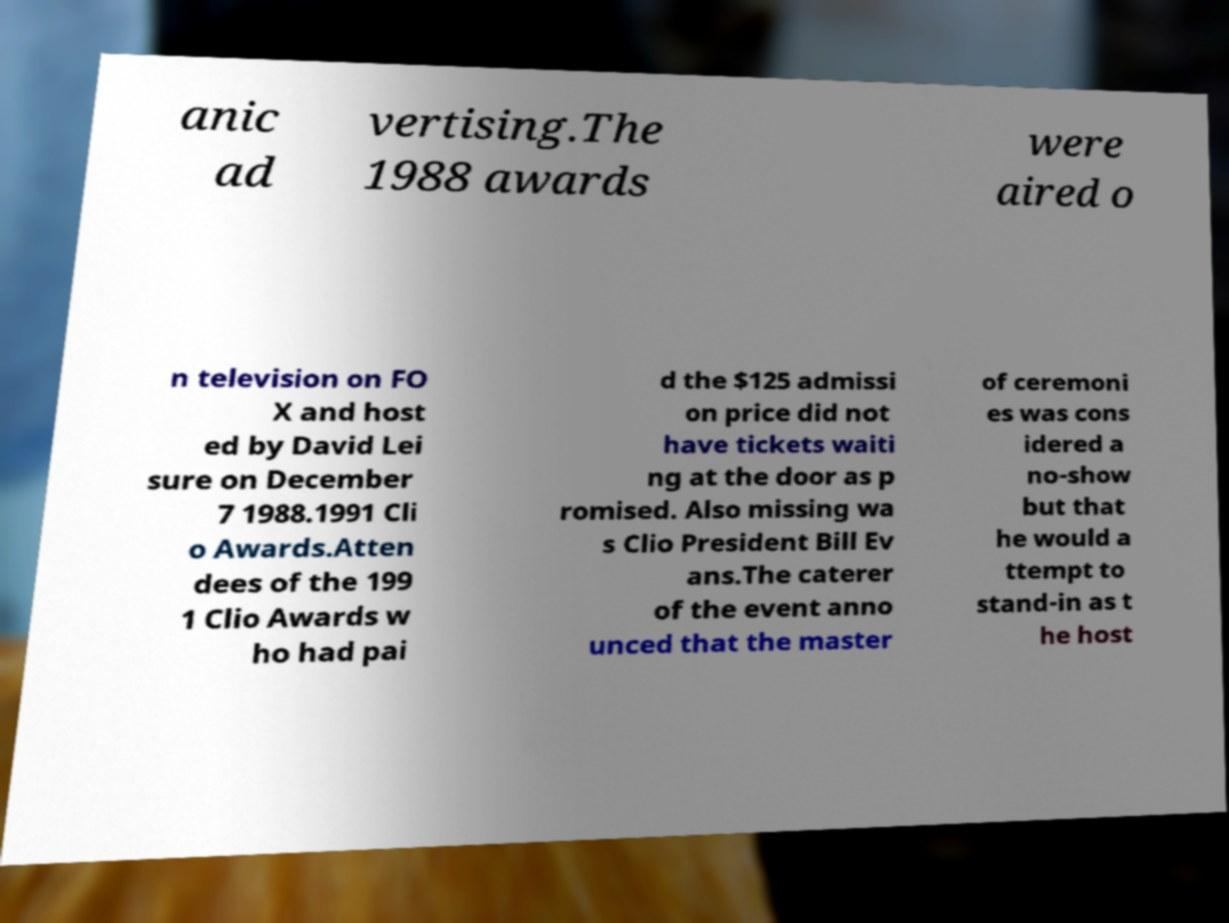Could you extract and type out the text from this image? anic ad vertising.The 1988 awards were aired o n television on FO X and host ed by David Lei sure on December 7 1988.1991 Cli o Awards.Atten dees of the 199 1 Clio Awards w ho had pai d the $125 admissi on price did not have tickets waiti ng at the door as p romised. Also missing wa s Clio President Bill Ev ans.The caterer of the event anno unced that the master of ceremoni es was cons idered a no-show but that he would a ttempt to stand-in as t he host 